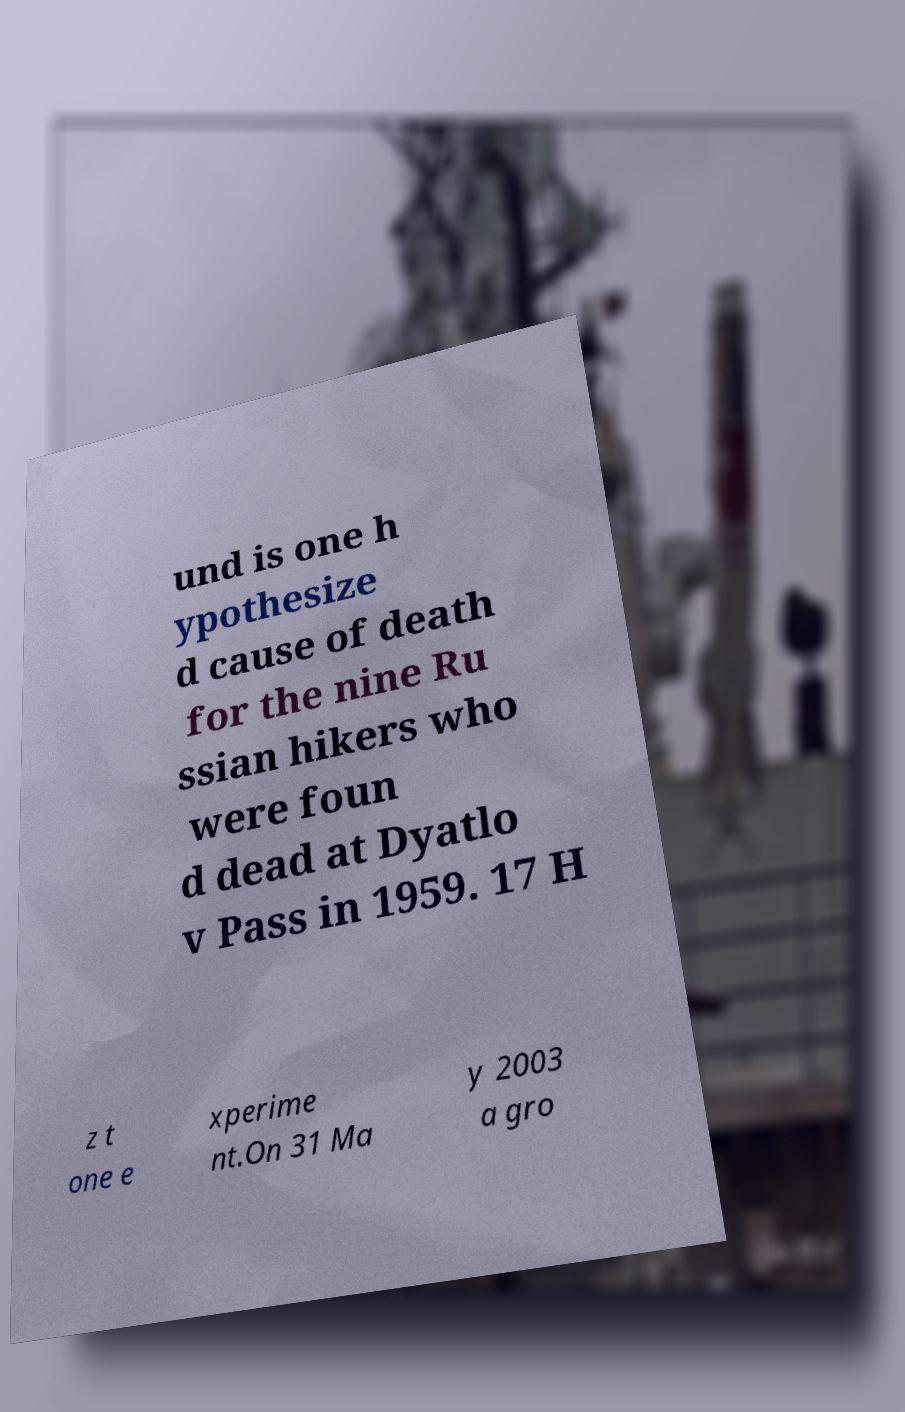Could you extract and type out the text from this image? und is one h ypothesize d cause of death for the nine Ru ssian hikers who were foun d dead at Dyatlo v Pass in 1959. 17 H z t one e xperime nt.On 31 Ma y 2003 a gro 